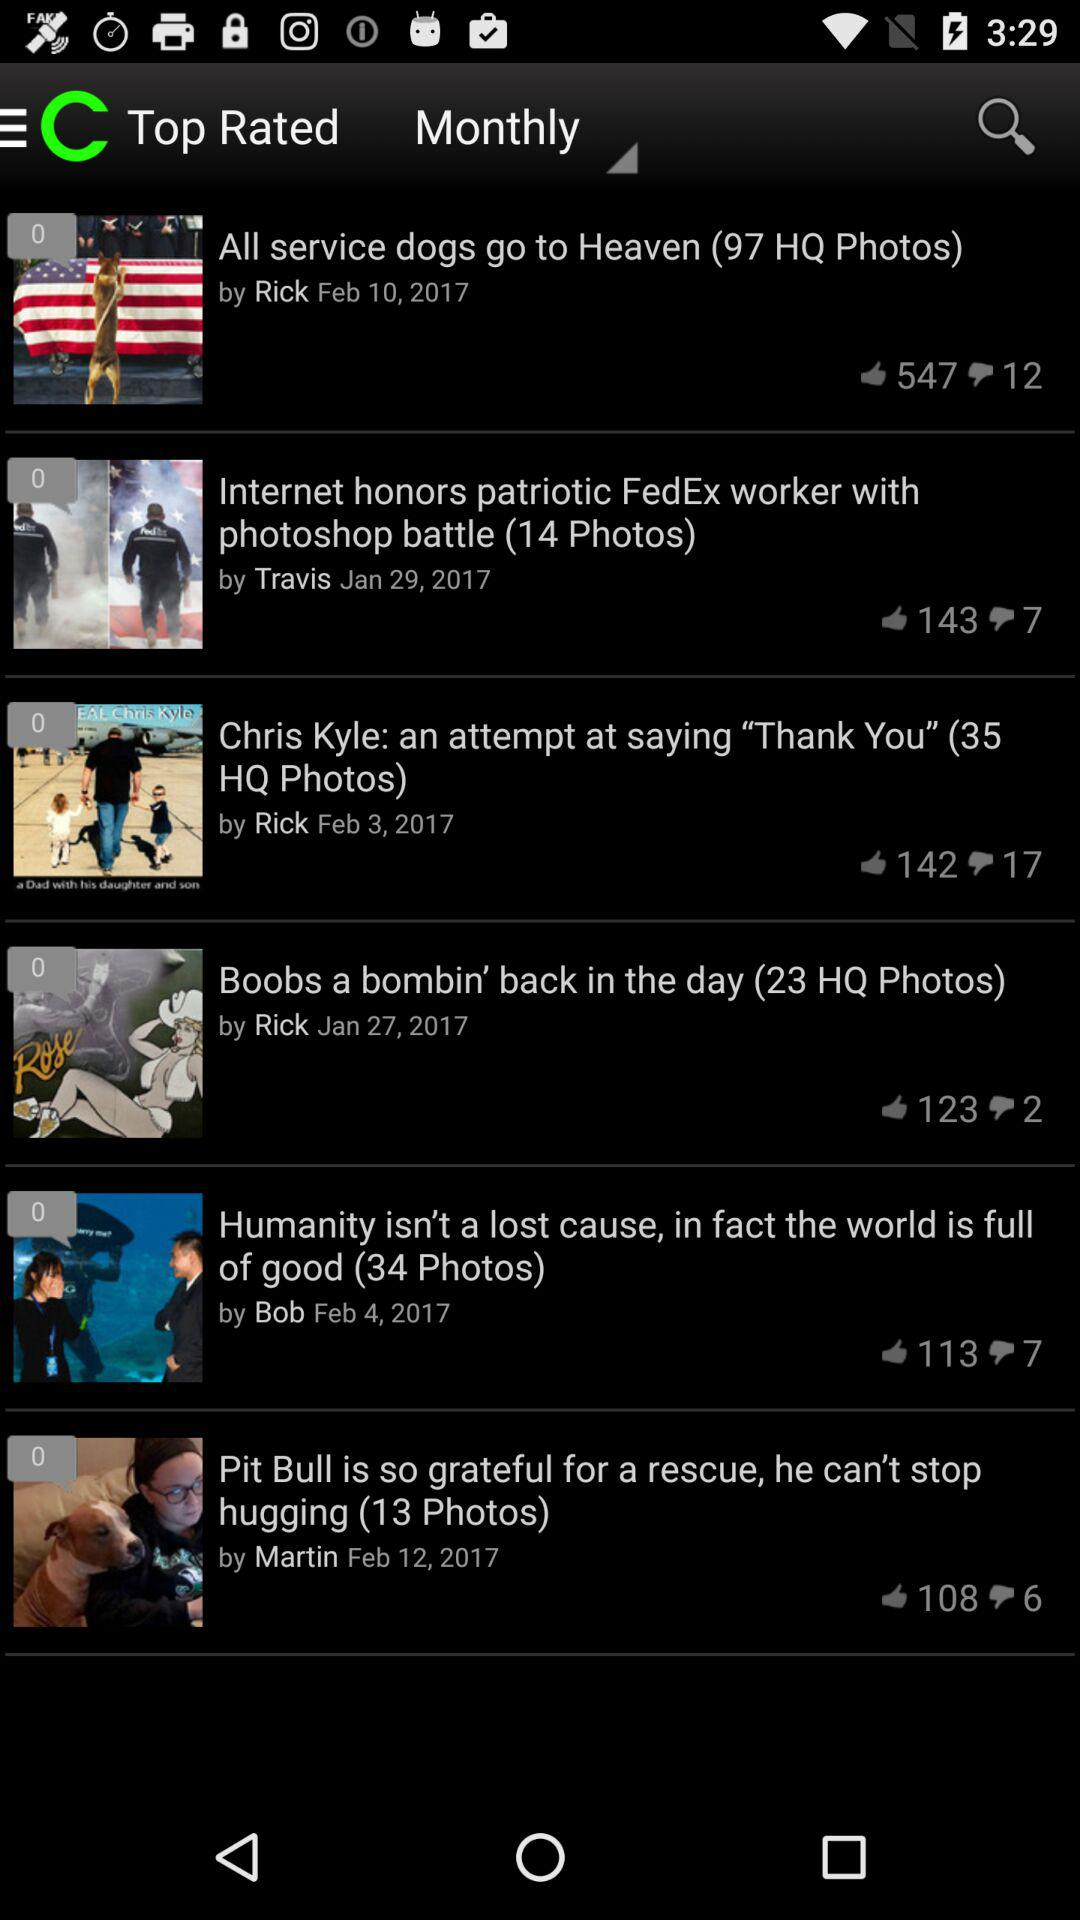What is the headline of the news posted on February 10, 2017? The headline is "All service dogs go to Heaven (97 HQ Photos)". 